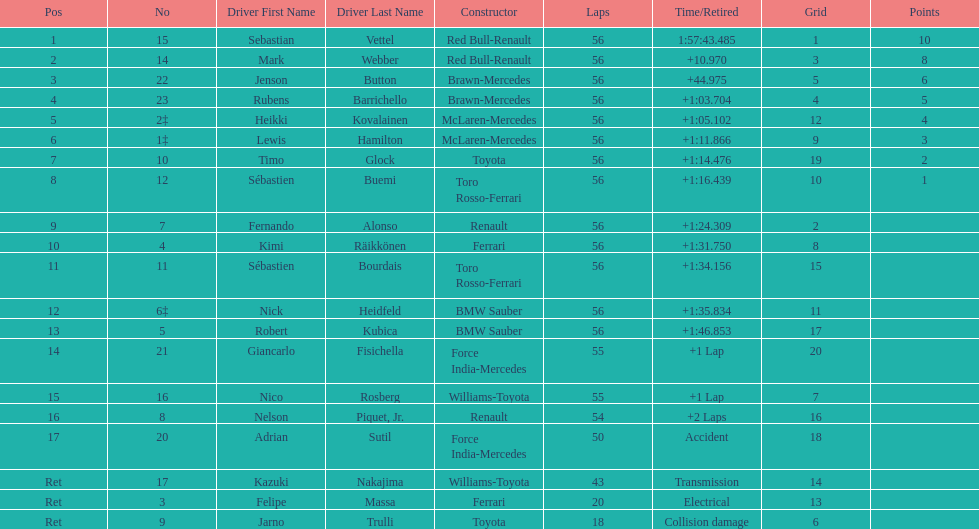How many drivers did not finish 56 laps? 7. 